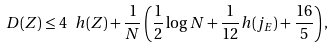Convert formula to latex. <formula><loc_0><loc_0><loc_500><loc_500>\ D ( Z ) \leq 4 \ h ( Z ) + \frac { 1 } { N } \left ( \frac { 1 } { 2 } \log N + \frac { 1 } { 1 2 } h ( j _ { E } ) + \frac { 1 6 } { 5 } \right ) ,</formula> 